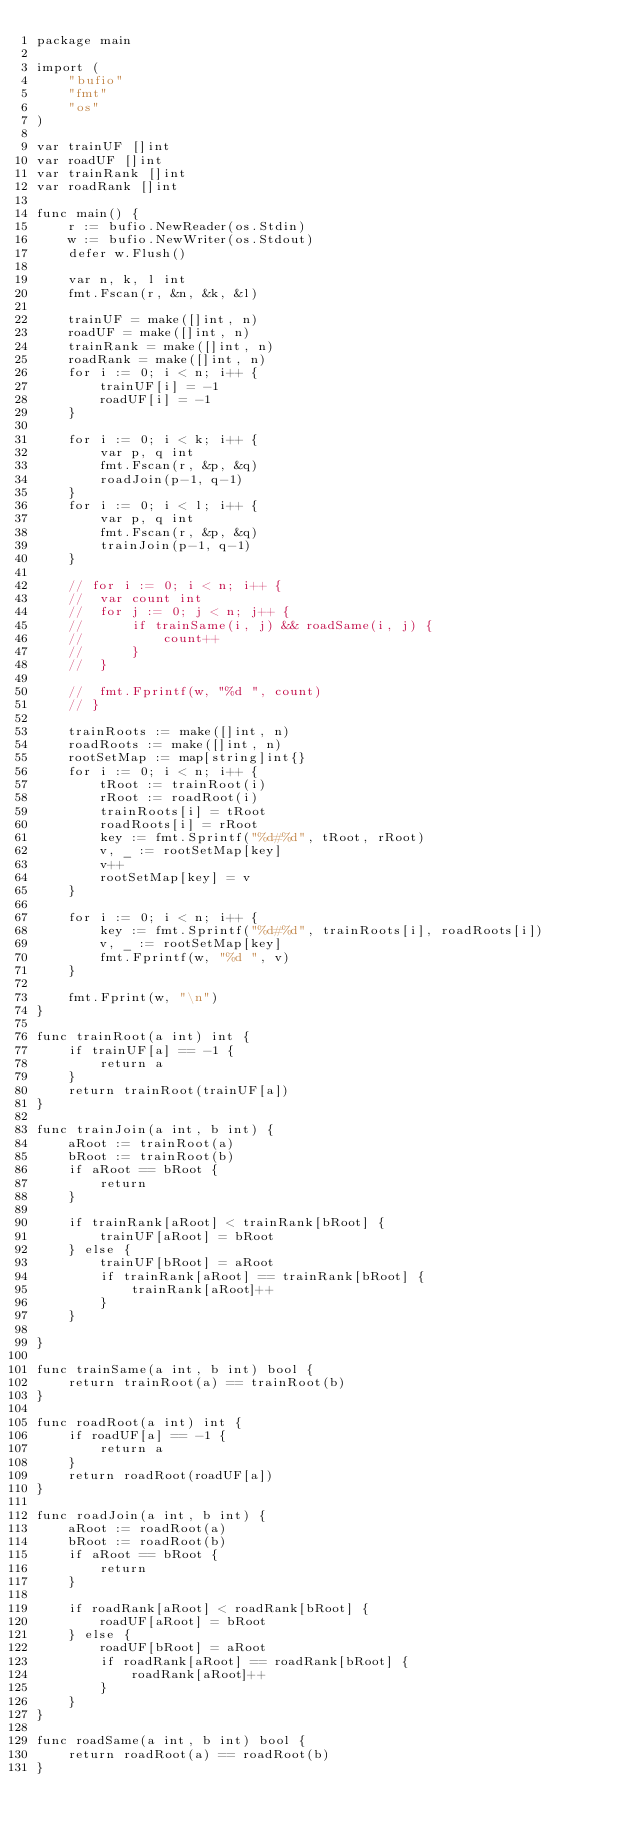Convert code to text. <code><loc_0><loc_0><loc_500><loc_500><_Go_>package main

import (
	"bufio"
	"fmt"
	"os"
)

var trainUF []int
var roadUF []int
var trainRank []int
var roadRank []int

func main() {
	r := bufio.NewReader(os.Stdin)
	w := bufio.NewWriter(os.Stdout)
	defer w.Flush()

	var n, k, l int
	fmt.Fscan(r, &n, &k, &l)

	trainUF = make([]int, n)
	roadUF = make([]int, n)
	trainRank = make([]int, n)
	roadRank = make([]int, n)
	for i := 0; i < n; i++ {
		trainUF[i] = -1
		roadUF[i] = -1
	}

	for i := 0; i < k; i++ {
		var p, q int
		fmt.Fscan(r, &p, &q)
		roadJoin(p-1, q-1)
	}
	for i := 0; i < l; i++ {
		var p, q int
		fmt.Fscan(r, &p, &q)
		trainJoin(p-1, q-1)
	}

	// for i := 0; i < n; i++ {
	// 	var count int
	// 	for j := 0; j < n; j++ {
	// 		if trainSame(i, j) && roadSame(i, j) {
	// 			count++
	// 		}
	// 	}

	// 	fmt.Fprintf(w, "%d ", count)
	// }

	trainRoots := make([]int, n)
	roadRoots := make([]int, n)
	rootSetMap := map[string]int{}
	for i := 0; i < n; i++ {
		tRoot := trainRoot(i)
		rRoot := roadRoot(i)
		trainRoots[i] = tRoot
		roadRoots[i] = rRoot
		key := fmt.Sprintf("%d#%d", tRoot, rRoot)
		v, _ := rootSetMap[key]
		v++
		rootSetMap[key] = v
	}

	for i := 0; i < n; i++ {
		key := fmt.Sprintf("%d#%d", trainRoots[i], roadRoots[i])
		v, _ := rootSetMap[key]
		fmt.Fprintf(w, "%d ", v)
	}

	fmt.Fprint(w, "\n")
}

func trainRoot(a int) int {
	if trainUF[a] == -1 {
		return a
	}
	return trainRoot(trainUF[a])
}

func trainJoin(a int, b int) {
	aRoot := trainRoot(a)
	bRoot := trainRoot(b)
	if aRoot == bRoot {
		return
	}

	if trainRank[aRoot] < trainRank[bRoot] {
		trainUF[aRoot] = bRoot
	} else {
		trainUF[bRoot] = aRoot
		if trainRank[aRoot] == trainRank[bRoot] {
			trainRank[aRoot]++
		}
	}

}

func trainSame(a int, b int) bool {
	return trainRoot(a) == trainRoot(b)
}

func roadRoot(a int) int {
	if roadUF[a] == -1 {
		return a
	}
	return roadRoot(roadUF[a])
}

func roadJoin(a int, b int) {
	aRoot := roadRoot(a)
	bRoot := roadRoot(b)
	if aRoot == bRoot {
		return
	}

	if roadRank[aRoot] < roadRank[bRoot] {
		roadUF[aRoot] = bRoot
	} else {
		roadUF[bRoot] = aRoot
		if roadRank[aRoot] == roadRank[bRoot] {
			roadRank[aRoot]++
		}
	}
}

func roadSame(a int, b int) bool {
	return roadRoot(a) == roadRoot(b)
}
</code> 